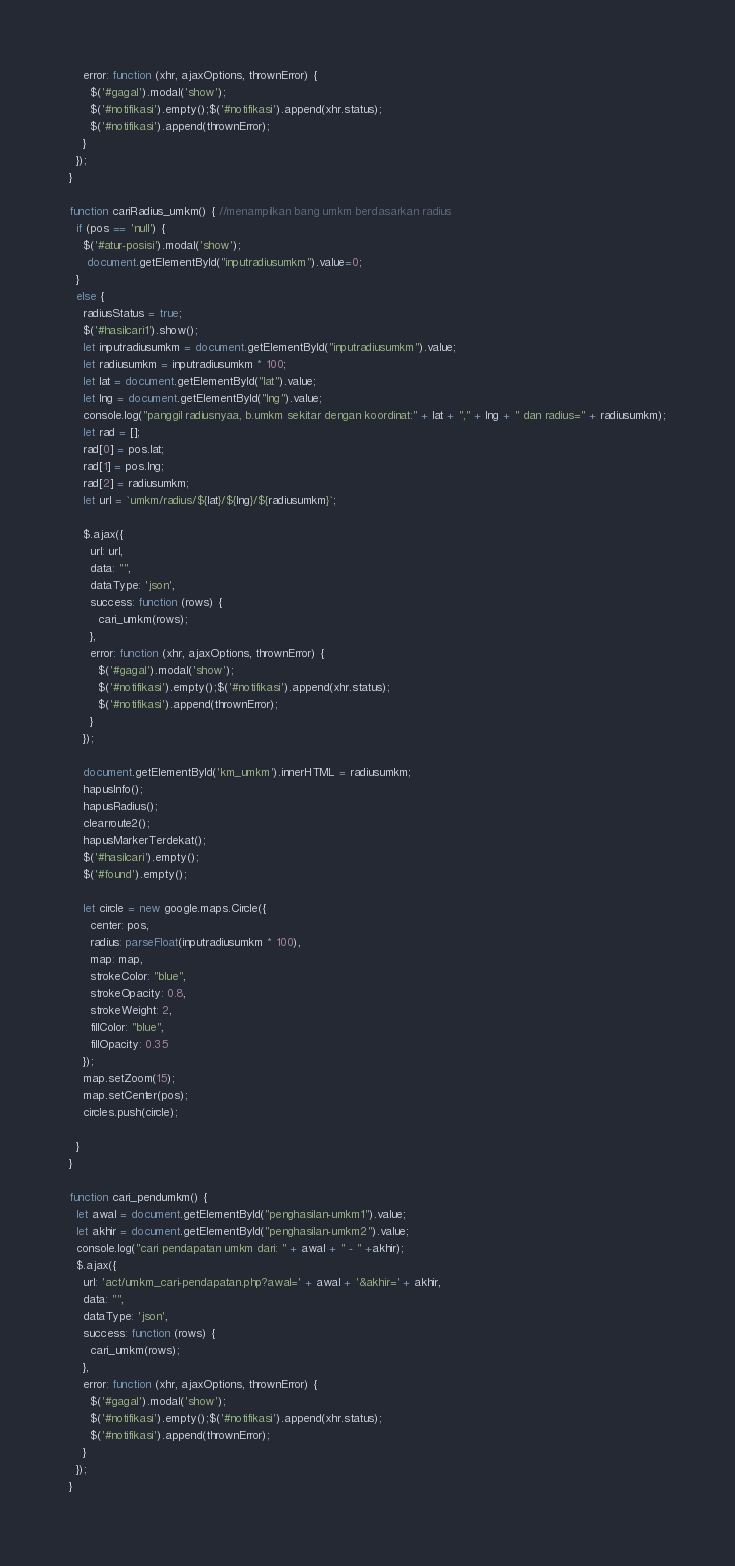Convert code to text. <code><loc_0><loc_0><loc_500><loc_500><_JavaScript_>    error: function (xhr, ajaxOptions, thrownError) {
      $('#gagal').modal('show');
      $('#notifikasi').empty();$('#notifikasi').append(xhr.status);
      $('#notifikasi').append(thrownError);
    }
  });
}

function cariRadius_umkm() { //menampilkan bang umkm berdasarkan radius
  if (pos == 'null') {
    $('#atur-posisi').modal('show');
     document.getElementById("inputradiusumkm").value=0;
  }
  else {
    radiusStatus = true;
    $('#hasilcari1').show();
    let inputradiusumkm = document.getElementById("inputradiusumkm").value;
    let radiusumkm = inputradiusumkm * 100;
    let lat = document.getElementById("lat").value;
    let lng = document.getElementById("lng").value;
    console.log("panggil radiusnyaa, b.umkm sekitar dengan koordinat:" + lat + "," + lng + " dan radius=" + radiusumkm);
    let rad = [];
    rad[0] = pos.lat;
    rad[1] = pos.lng;
    rad[2] = radiusumkm;
    let url = `umkm/radius/${lat}/${lng}/${radiusumkm}`;
    
    $.ajax({
      url: url,
      data: "",
      dataType: 'json',
      success: function (rows) {
        cari_umkm(rows);
      },
      error: function (xhr, ajaxOptions, thrownError) {
        $('#gagal').modal('show');
        $('#notifikasi').empty();$('#notifikasi').append(xhr.status);
        $('#notifikasi').append(thrownError);
      }
    });

    document.getElementById('km_umkm').innerHTML = radiusumkm;
    hapusInfo();
    hapusRadius();
    clearroute2();
    hapusMarkerTerdekat();
    $('#hasilcari').empty();
    $('#found').empty();
    
    let circle = new google.maps.Circle({
      center: pos,
      radius: parseFloat(inputradiusumkm * 100),
      map: map,
      strokeColor: "blue",
      strokeOpacity: 0.8,
      strokeWeight: 2,
      fillColor: "blue",
      fillOpacity: 0.35
    });
    map.setZoom(15);
    map.setCenter(pos);
    circles.push(circle); 
      
  }
}

function cari_pendumkm() { 
  let awal = document.getElementById("penghasilan-umkm1").value;
  let akhir = document.getElementById("penghasilan-umkm2").value;
  console.log("cari pendapatan umkm dari: " + awal + " - " +akhir);
  $.ajax({
    url: 'act/umkm_cari-pendapatan.php?awal=' + awal + '&akhir=' + akhir,
    data: "",
    dataType: 'json',
    success: function (rows) {
      cari_umkm(rows);
    },
    error: function (xhr, ajaxOptions, thrownError) {
      $('#gagal').modal('show');
      $('#notifikasi').empty();$('#notifikasi').append(xhr.status);
      $('#notifikasi').append(thrownError);
    }
  });
}</code> 